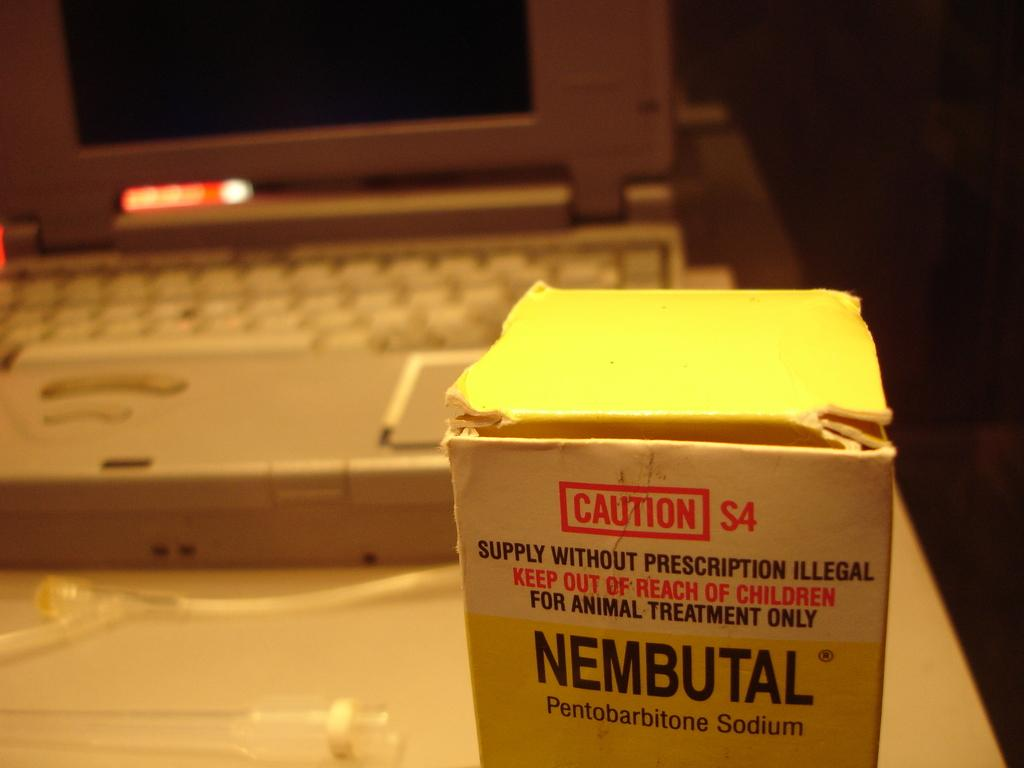<image>
Offer a succinct explanation of the picture presented. A box of Nebutal Pentobarbitone Sodium sits in front of a laptop. 